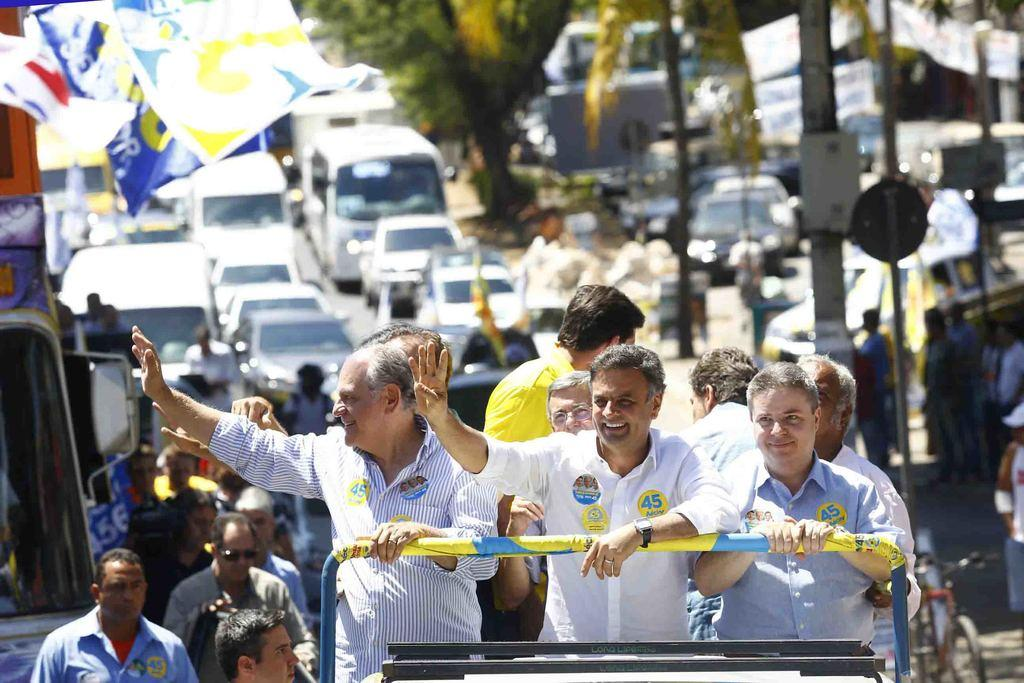What can be seen in the foreground of the image? There are persons standing in the front of the image. What is the facial expression of the persons in the image? The persons are smiling. What is visible in the background of the image? There are cars, flags, trees, and persons in the background of the image. What structures can be seen in the background of the image? There are poles in the background of the image. What type of credit can be seen being given to the army in the image? There is no army or credit present in the image. What scene is being depicted in the image? The image does not depict a specific scene; it shows persons standing and smiling, along with various objects and structures in the background. 